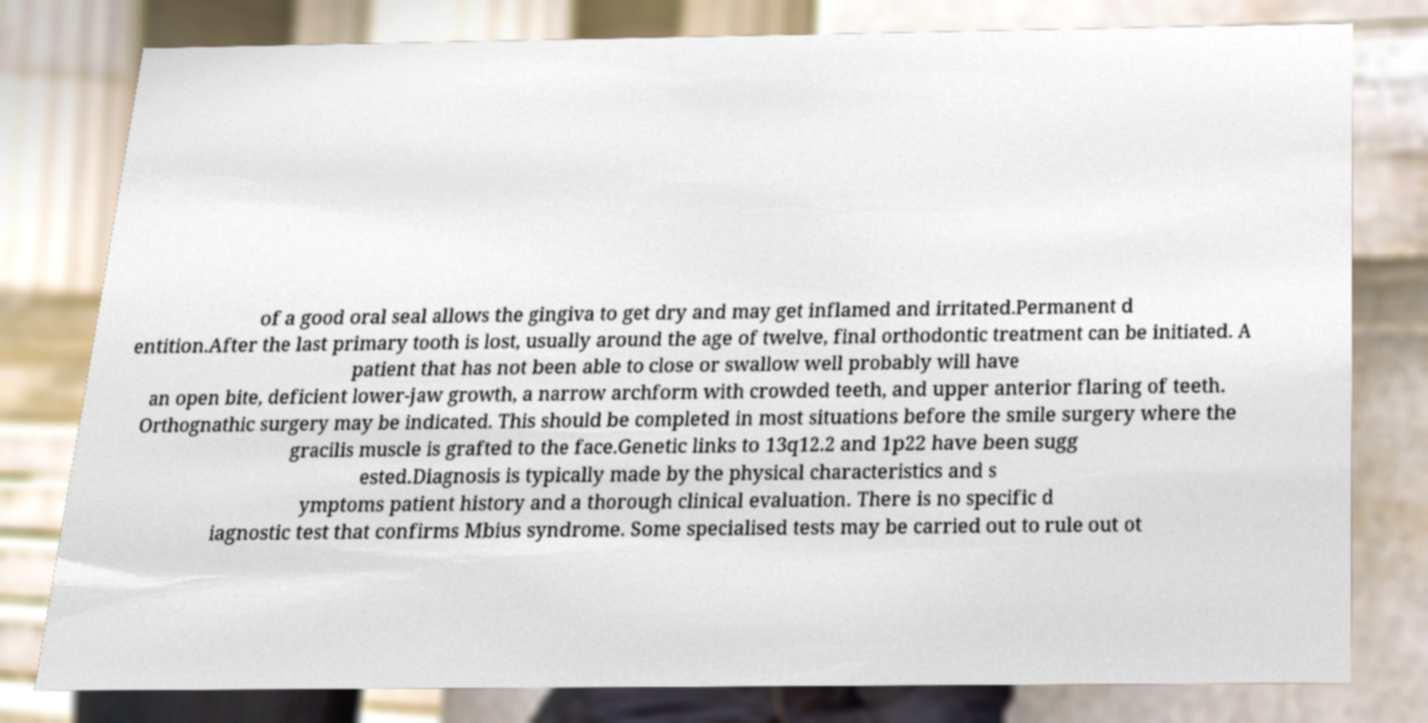I need the written content from this picture converted into text. Can you do that? of a good oral seal allows the gingiva to get dry and may get inflamed and irritated.Permanent d entition.After the last primary tooth is lost, usually around the age of twelve, final orthodontic treatment can be initiated. A patient that has not been able to close or swallow well probably will have an open bite, deficient lower-jaw growth, a narrow archform with crowded teeth, and upper anterior flaring of teeth. Orthognathic surgery may be indicated. This should be completed in most situations before the smile surgery where the gracilis muscle is grafted to the face.Genetic links to 13q12.2 and 1p22 have been sugg ested.Diagnosis is typically made by the physical characteristics and s ymptoms patient history and a thorough clinical evaluation. There is no specific d iagnostic test that confirms Mbius syndrome. Some specialised tests may be carried out to rule out ot 